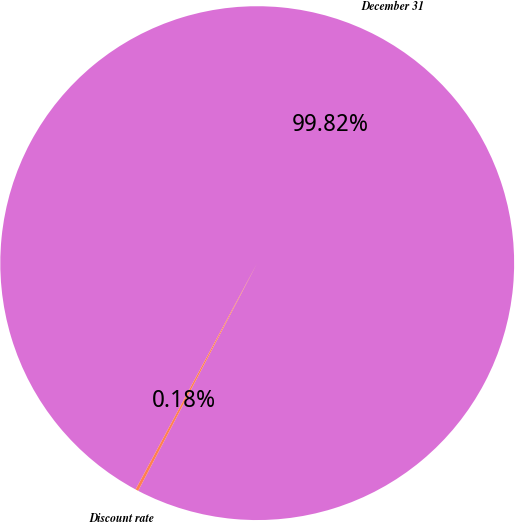Convert chart. <chart><loc_0><loc_0><loc_500><loc_500><pie_chart><fcel>December 31<fcel>Discount rate<nl><fcel>99.82%<fcel>0.18%<nl></chart> 